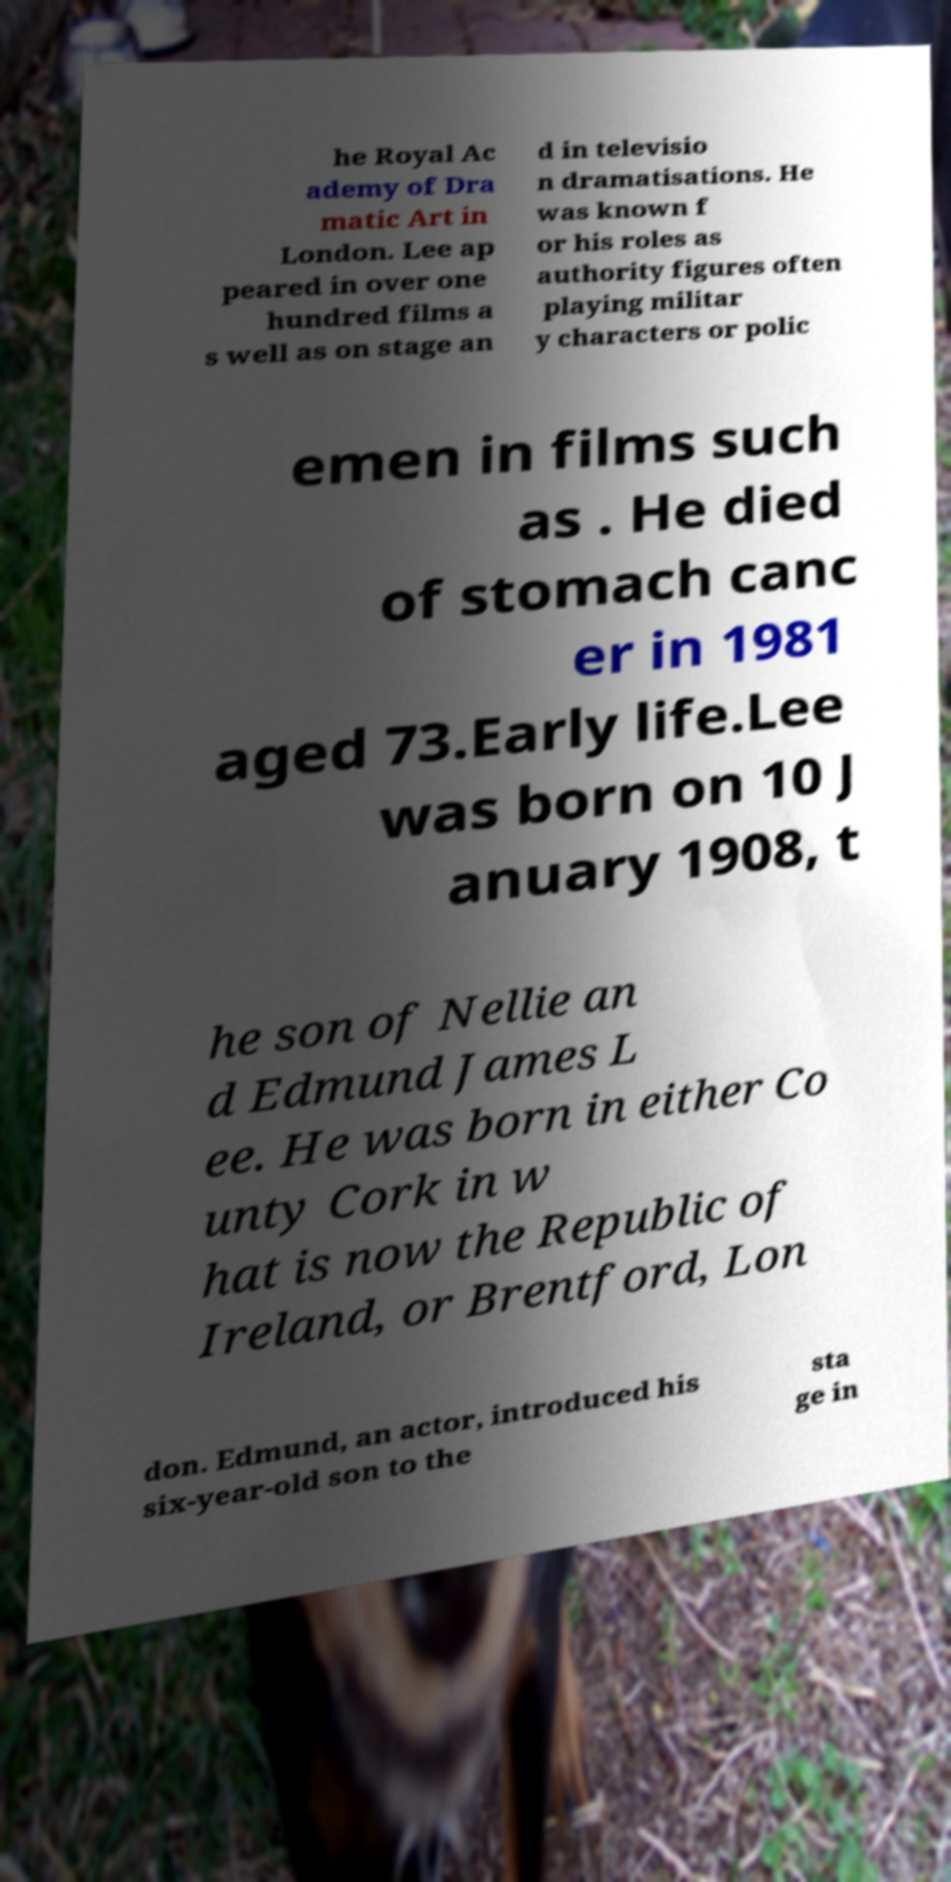I need the written content from this picture converted into text. Can you do that? he Royal Ac ademy of Dra matic Art in London. Lee ap peared in over one hundred films a s well as on stage an d in televisio n dramatisations. He was known f or his roles as authority figures often playing militar y characters or polic emen in films such as . He died of stomach canc er in 1981 aged 73.Early life.Lee was born on 10 J anuary 1908, t he son of Nellie an d Edmund James L ee. He was born in either Co unty Cork in w hat is now the Republic of Ireland, or Brentford, Lon don. Edmund, an actor, introduced his six-year-old son to the sta ge in 